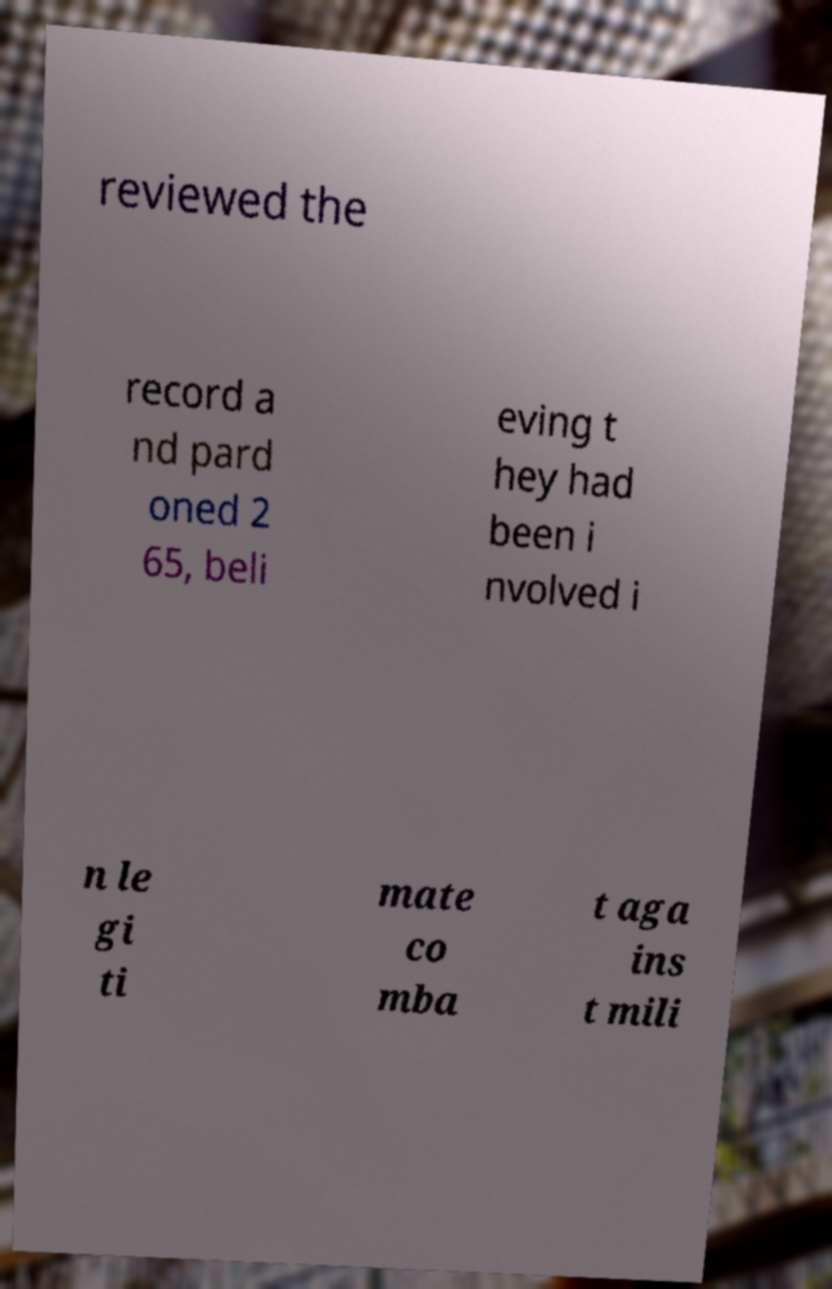There's text embedded in this image that I need extracted. Can you transcribe it verbatim? reviewed the record a nd pard oned 2 65, beli eving t hey had been i nvolved i n le gi ti mate co mba t aga ins t mili 